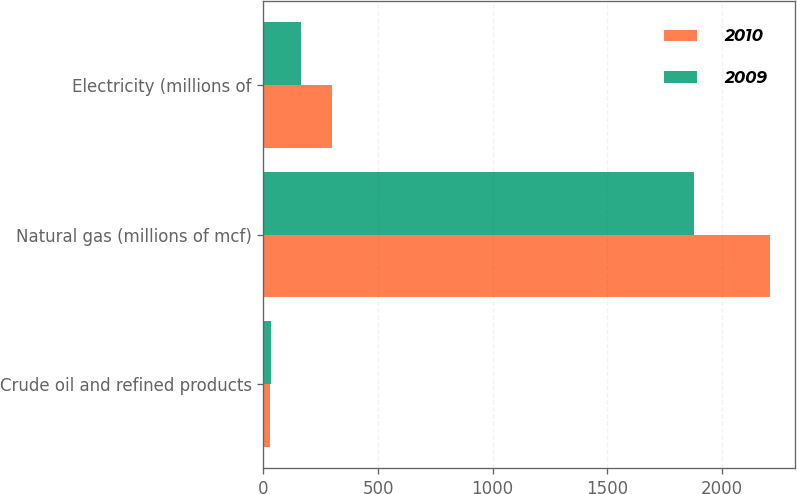Convert chart. <chart><loc_0><loc_0><loc_500><loc_500><stacked_bar_chart><ecel><fcel>Crude oil and refined products<fcel>Natural gas (millions of mcf)<fcel>Electricity (millions of<nl><fcel>2010<fcel>30<fcel>2210<fcel>301<nl><fcel>2009<fcel>34<fcel>1876<fcel>166<nl></chart> 